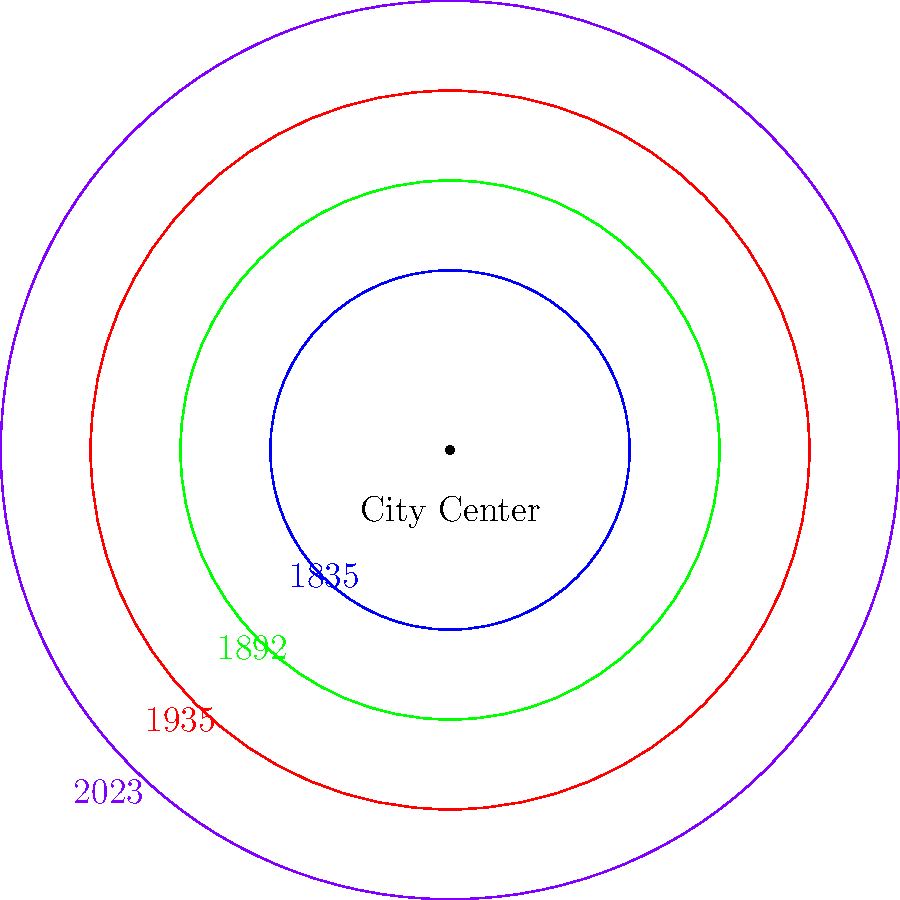Based on the diagram showing Leicester's city boundary expansions, what is the approximate percentage increase in the city's area from 1835 to 2023? To calculate the percentage increase in Leicester's city area from 1835 to 2023, we'll follow these steps:

1. Observe that the city boundaries are represented by concentric circles.
2. The area of a circle is proportional to the square of its radius.
3. In the diagram, the 1835 boundary has a radius of 1 unit, while the 2023 boundary has a radius of 2.5 units.
4. Calculate the ratio of areas:
   $$ \text{Ratio} = \frac{\text{Area}_{\text{2023}}}{\text{Area}_{\text{1835}}} = \frac{\pi r_{2023}^2}{\pi r_{1835}^2} = \frac{(2.5)^2}{(1)^2} = 6.25 $$
5. Convert this ratio to a percentage increase:
   $$ \text{Percentage increase} = (\text{Ratio} - 1) \times 100\% $$
   $$ = (6.25 - 1) \times 100\% = 5.25 \times 100\% = 525\% $$

Therefore, the approximate percentage increase in Leicester's city area from 1835 to 2023 is 525%.
Answer: 525% 